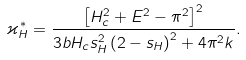<formula> <loc_0><loc_0><loc_500><loc_500>\varkappa _ { H } ^ { * } = \frac { \left [ H ^ { 2 } _ { c } + E ^ { 2 } - \pi ^ { 2 } \right ] ^ { 2 } } { 3 b H _ { c } s _ { H } ^ { 2 } \left ( 2 - s _ { H } \right ) ^ { 2 } + 4 \pi ^ { 2 } k } .</formula> 